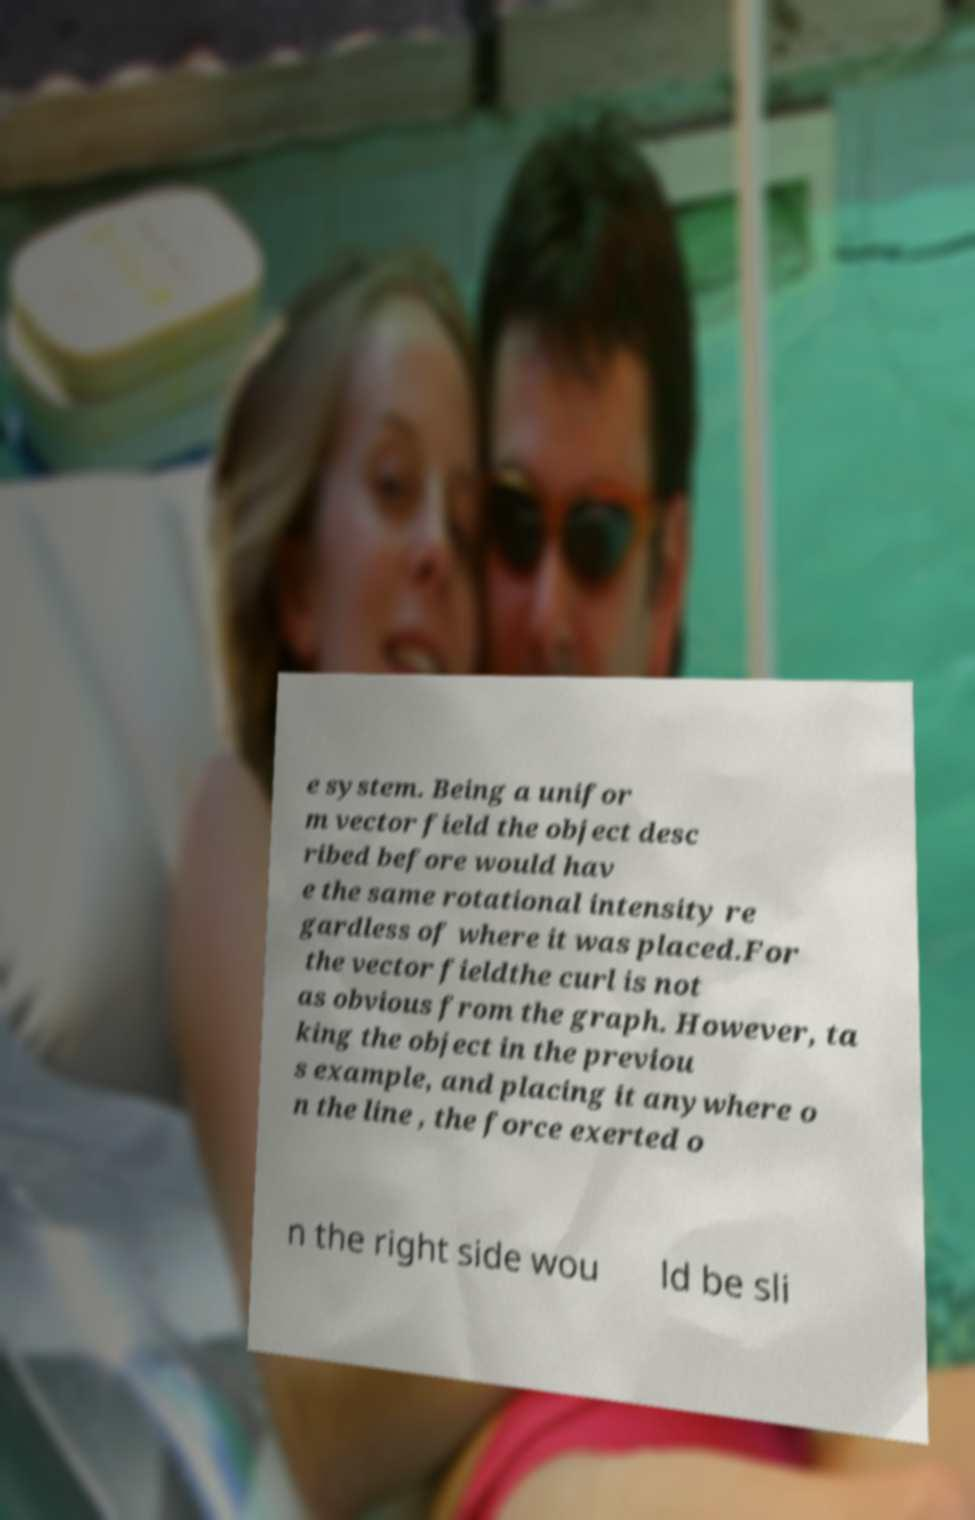I need the written content from this picture converted into text. Can you do that? e system. Being a unifor m vector field the object desc ribed before would hav e the same rotational intensity re gardless of where it was placed.For the vector fieldthe curl is not as obvious from the graph. However, ta king the object in the previou s example, and placing it anywhere o n the line , the force exerted o n the right side wou ld be sli 